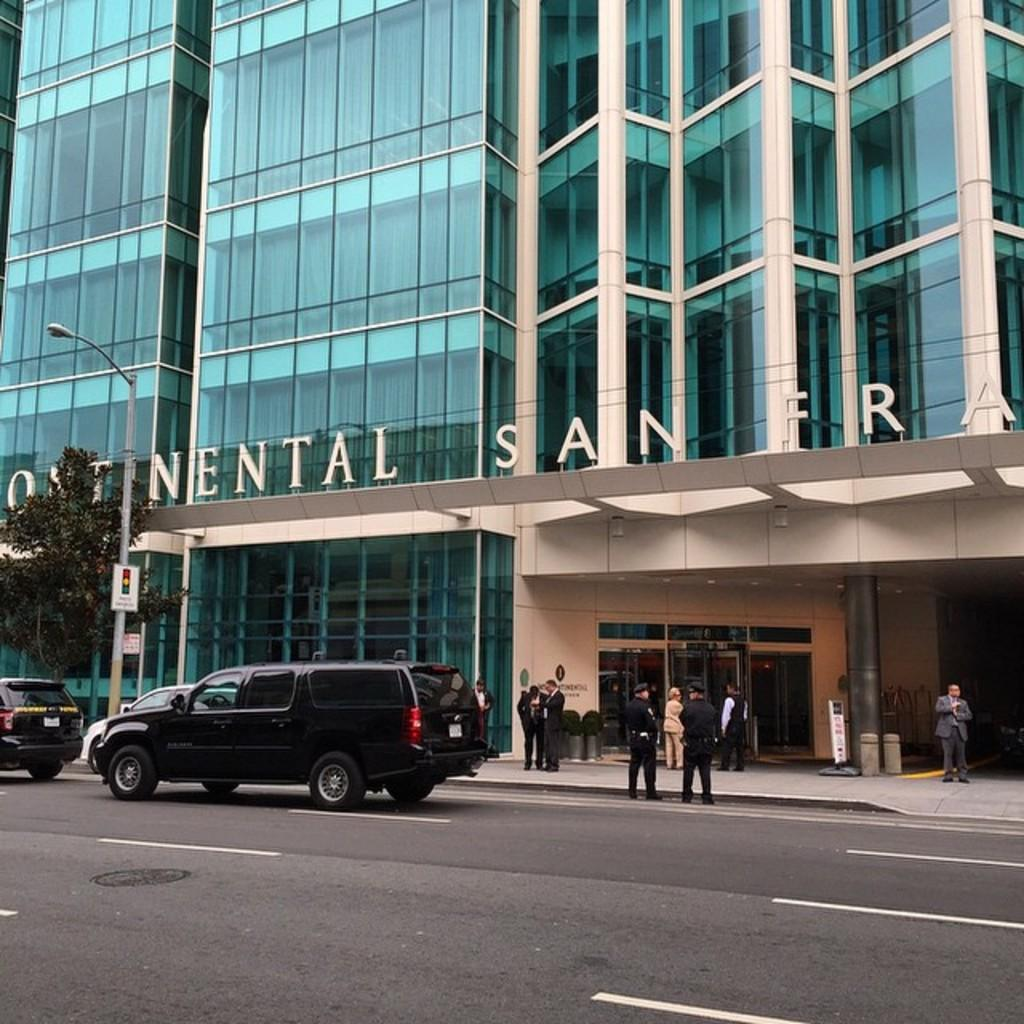Who or what can be seen in the image? There are people in the image. What is the primary feature of the environment in the image? There is a road in the image. What types of transportation are present in the image? Vehicles are present in the image. What structures can be seen in the image? Poles, lights, trees, posters, and a building with doors are visible in the image. What additional details can be observed on the building? There is some text on the building. What type of beef is being served at the restaurant in the image? There is no restaurant or beef present in the image. How many stitches are visible on the clothing of the people in the image? There is no information about clothing or stitches in the image. 